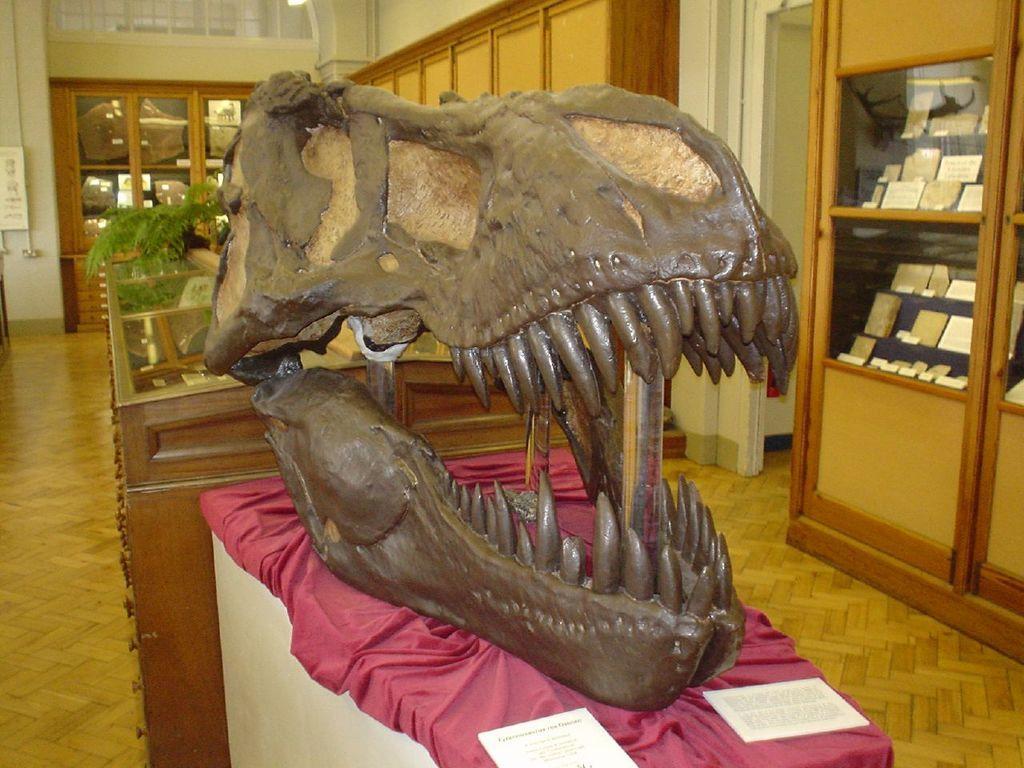Describe this image in one or two sentences. In front of the image there is an artifact with some descriptive notes on a table, behind that there are some artifacts on the glass display, on the right side of the image there is a door and there are pipes, metal rod windows and some objects on the wall. 